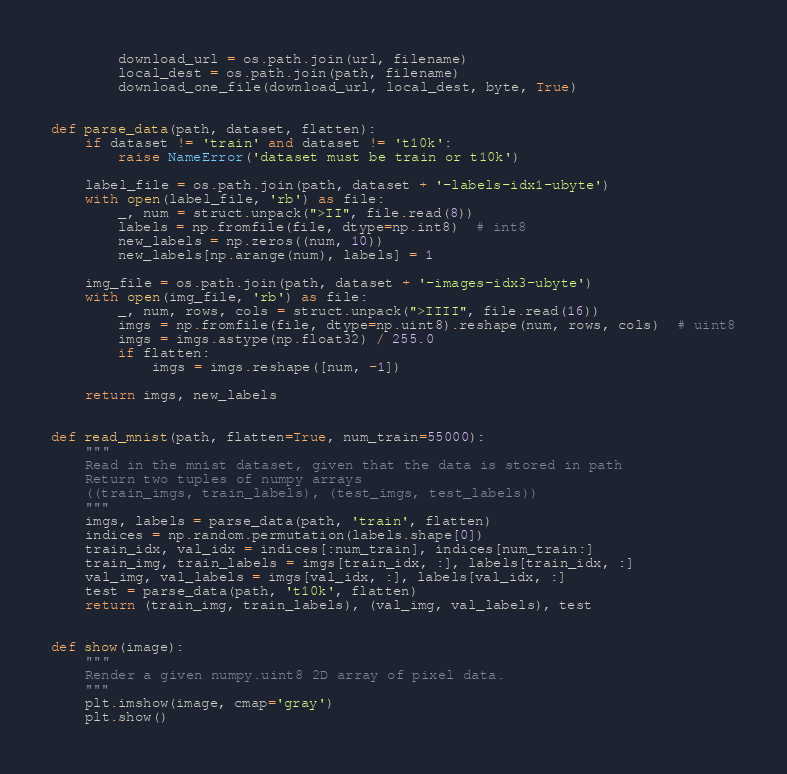<code> <loc_0><loc_0><loc_500><loc_500><_Python_>        download_url = os.path.join(url, filename)
        local_dest = os.path.join(path, filename)
        download_one_file(download_url, local_dest, byte, True)


def parse_data(path, dataset, flatten):
    if dataset != 'train' and dataset != 't10k':
        raise NameError('dataset must be train or t10k')

    label_file = os.path.join(path, dataset + '-labels-idx1-ubyte')
    with open(label_file, 'rb') as file:
        _, num = struct.unpack(">II", file.read(8))
        labels = np.fromfile(file, dtype=np.int8)  # int8
        new_labels = np.zeros((num, 10))
        new_labels[np.arange(num), labels] = 1

    img_file = os.path.join(path, dataset + '-images-idx3-ubyte')
    with open(img_file, 'rb') as file:
        _, num, rows, cols = struct.unpack(">IIII", file.read(16))
        imgs = np.fromfile(file, dtype=np.uint8).reshape(num, rows, cols)  # uint8
        imgs = imgs.astype(np.float32) / 255.0
        if flatten:
            imgs = imgs.reshape([num, -1])

    return imgs, new_labels


def read_mnist(path, flatten=True, num_train=55000):
    """
    Read in the mnist dataset, given that the data is stored in path
    Return two tuples of numpy arrays
    ((train_imgs, train_labels), (test_imgs, test_labels))
    """
    imgs, labels = parse_data(path, 'train', flatten)
    indices = np.random.permutation(labels.shape[0])
    train_idx, val_idx = indices[:num_train], indices[num_train:]
    train_img, train_labels = imgs[train_idx, :], labels[train_idx, :]
    val_img, val_labels = imgs[val_idx, :], labels[val_idx, :]
    test = parse_data(path, 't10k', flatten)
    return (train_img, train_labels), (val_img, val_labels), test


def show(image):
    """
    Render a given numpy.uint8 2D array of pixel data.
    """
    plt.imshow(image, cmap='gray')
    plt.show()</code> 